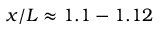Convert formula to latex. <formula><loc_0><loc_0><loc_500><loc_500>x / L \approx 1 . 1 - 1 . 1 2</formula> 